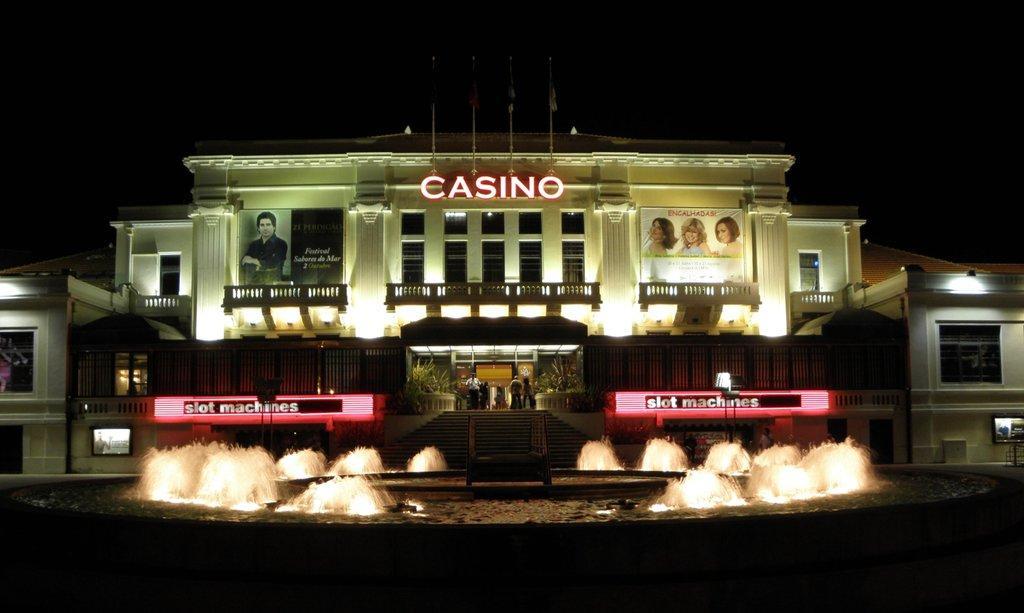Please provide a concise description of this image. In this image in the center there are some buildings and lights and in the foreground there is one fountain and also we could see some boards, on the boards there is some text. 